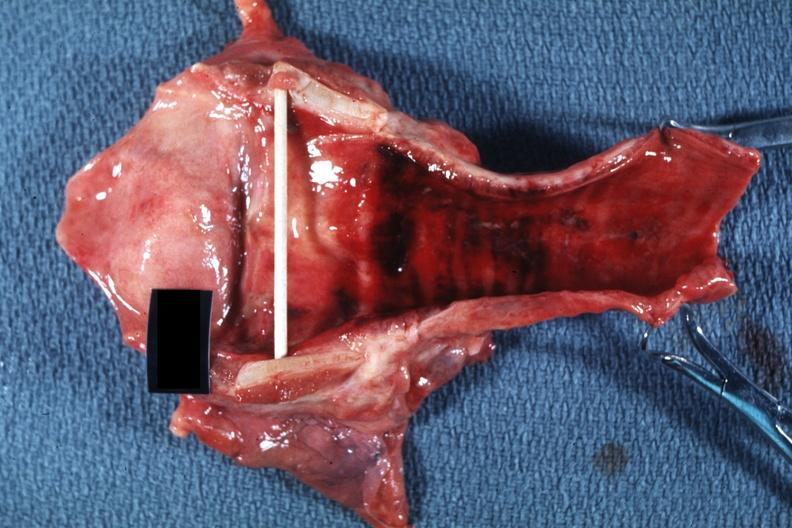s this person present?
Answer the question using a single word or phrase. No 